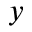Convert formula to latex. <formula><loc_0><loc_0><loc_500><loc_500>_ { y }</formula> 